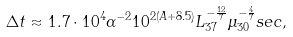Convert formula to latex. <formula><loc_0><loc_0><loc_500><loc_500>\Delta t \approx 1 . 7 \cdot 1 0 ^ { 4 } \alpha ^ { - 2 } 1 0 ^ { 2 ( A + 8 . 5 ) } L _ { 3 7 } ^ { - \frac { 1 2 } { 7 } } \mu _ { 3 0 } ^ { - \frac { 4 } { 7 } } s e c ,</formula> 